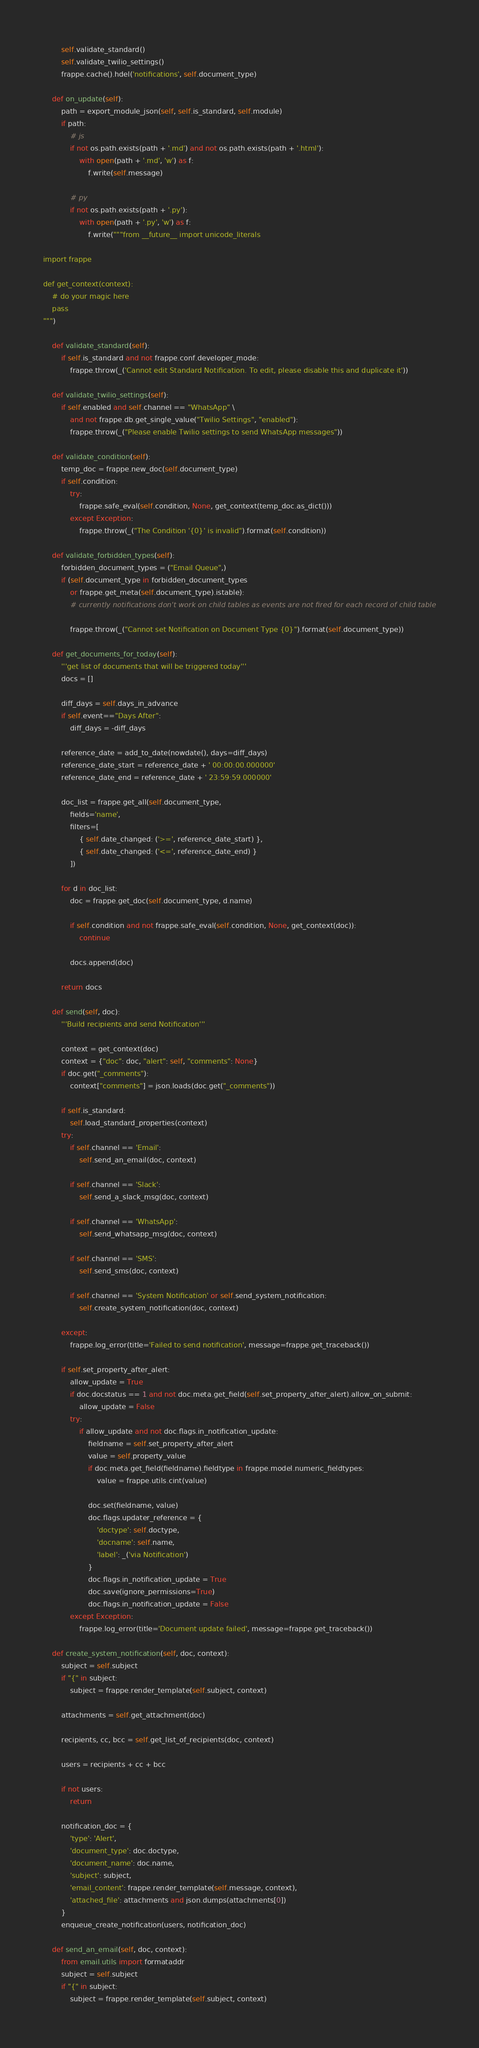<code> <loc_0><loc_0><loc_500><loc_500><_Python_>		self.validate_standard()
		self.validate_twilio_settings()
		frappe.cache().hdel('notifications', self.document_type)

	def on_update(self):
		path = export_module_json(self, self.is_standard, self.module)
		if path:
			# js
			if not os.path.exists(path + '.md') and not os.path.exists(path + '.html'):
				with open(path + '.md', 'w') as f:
					f.write(self.message)

			# py
			if not os.path.exists(path + '.py'):
				with open(path + '.py', 'w') as f:
					f.write("""from __future__ import unicode_literals

import frappe

def get_context(context):
	# do your magic here
	pass
""")

	def validate_standard(self):
		if self.is_standard and not frappe.conf.developer_mode:
			frappe.throw(_('Cannot edit Standard Notification. To edit, please disable this and duplicate it'))

	def validate_twilio_settings(self):
		if self.enabled and self.channel == "WhatsApp" \
			and not frappe.db.get_single_value("Twilio Settings", "enabled"):
			frappe.throw(_("Please enable Twilio settings to send WhatsApp messages"))

	def validate_condition(self):
		temp_doc = frappe.new_doc(self.document_type)
		if self.condition:
			try:
				frappe.safe_eval(self.condition, None, get_context(temp_doc.as_dict()))
			except Exception:
				frappe.throw(_("The Condition '{0}' is invalid").format(self.condition))

	def validate_forbidden_types(self):
		forbidden_document_types = ("Email Queue",)
		if (self.document_type in forbidden_document_types
			or frappe.get_meta(self.document_type).istable):
			# currently notifications don't work on child tables as events are not fired for each record of child table

			frappe.throw(_("Cannot set Notification on Document Type {0}").format(self.document_type))

	def get_documents_for_today(self):
		'''get list of documents that will be triggered today'''
		docs = []

		diff_days = self.days_in_advance
		if self.event=="Days After":
			diff_days = -diff_days

		reference_date = add_to_date(nowdate(), days=diff_days)
		reference_date_start = reference_date + ' 00:00:00.000000'
		reference_date_end = reference_date + ' 23:59:59.000000'

		doc_list = frappe.get_all(self.document_type,
			fields='name',
			filters=[
				{ self.date_changed: ('>=', reference_date_start) },
				{ self.date_changed: ('<=', reference_date_end) }
			])

		for d in doc_list:
			doc = frappe.get_doc(self.document_type, d.name)

			if self.condition and not frappe.safe_eval(self.condition, None, get_context(doc)):
				continue

			docs.append(doc)

		return docs

	def send(self, doc):
		'''Build recipients and send Notification'''

		context = get_context(doc)
		context = {"doc": doc, "alert": self, "comments": None}
		if doc.get("_comments"):
			context["comments"] = json.loads(doc.get("_comments"))

		if self.is_standard:
			self.load_standard_properties(context)
		try:
			if self.channel == 'Email':
				self.send_an_email(doc, context)

			if self.channel == 'Slack':
				self.send_a_slack_msg(doc, context)

			if self.channel == 'WhatsApp':
				self.send_whatsapp_msg(doc, context)

			if self.channel == 'SMS':
				self.send_sms(doc, context)

			if self.channel == 'System Notification' or self.send_system_notification:
				self.create_system_notification(doc, context)

		except:
			frappe.log_error(title='Failed to send notification', message=frappe.get_traceback())

		if self.set_property_after_alert:
			allow_update = True
			if doc.docstatus == 1 and not doc.meta.get_field(self.set_property_after_alert).allow_on_submit:
				allow_update = False
			try:
				if allow_update and not doc.flags.in_notification_update:
					fieldname = self.set_property_after_alert
					value = self.property_value
					if doc.meta.get_field(fieldname).fieldtype in frappe.model.numeric_fieldtypes:
						value = frappe.utils.cint(value)

					doc.set(fieldname, value)
					doc.flags.updater_reference = {
						'doctype': self.doctype,
						'docname': self.name,
						'label': _('via Notification')
					}
					doc.flags.in_notification_update = True
					doc.save(ignore_permissions=True)
					doc.flags.in_notification_update = False
			except Exception:
				frappe.log_error(title='Document update failed', message=frappe.get_traceback())

	def create_system_notification(self, doc, context):
		subject = self.subject
		if "{" in subject:
			subject = frappe.render_template(self.subject, context)

		attachments = self.get_attachment(doc)

		recipients, cc, bcc = self.get_list_of_recipients(doc, context)

		users = recipients + cc + bcc

		if not users:
			return

		notification_doc = {
			'type': 'Alert',
			'document_type': doc.doctype,
			'document_name': doc.name,
			'subject': subject,
			'email_content': frappe.render_template(self.message, context),
			'attached_file': attachments and json.dumps(attachments[0])
		}
		enqueue_create_notification(users, notification_doc)

	def send_an_email(self, doc, context):
		from email.utils import formataddr
		subject = self.subject
		if "{" in subject:
			subject = frappe.render_template(self.subject, context)
</code> 